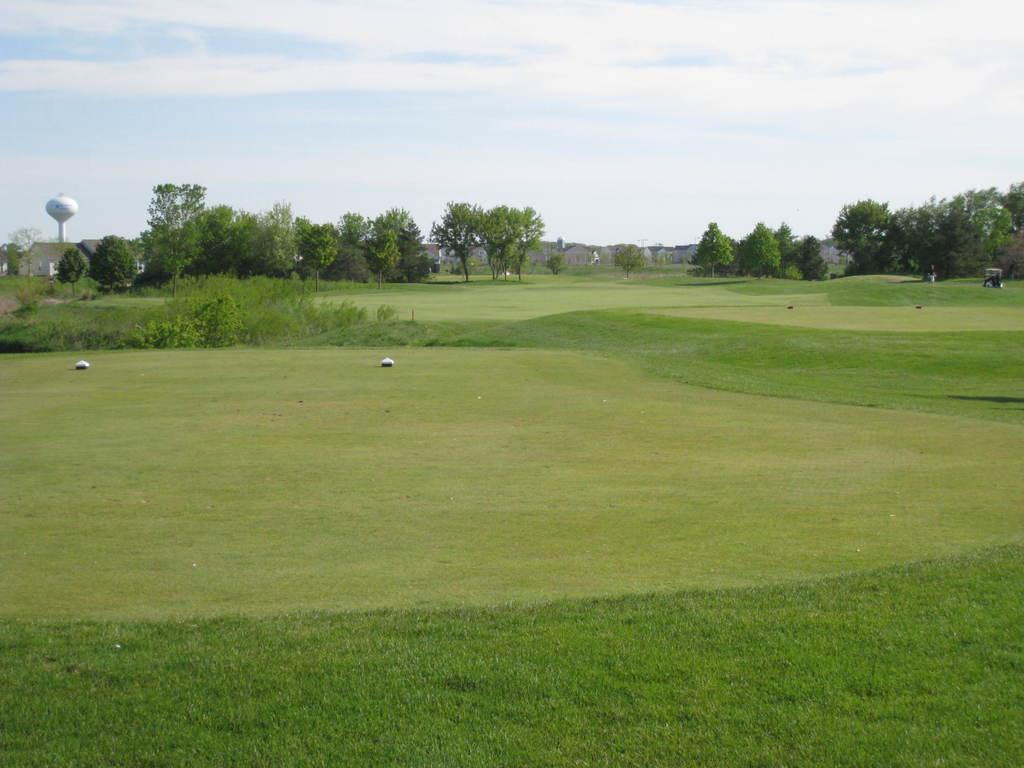Describe this image in one or two sentences. In this image I can see the ground. In the back there are many trees. To the left I can see the white color pole. In the back I can see the clouds and the sky. 